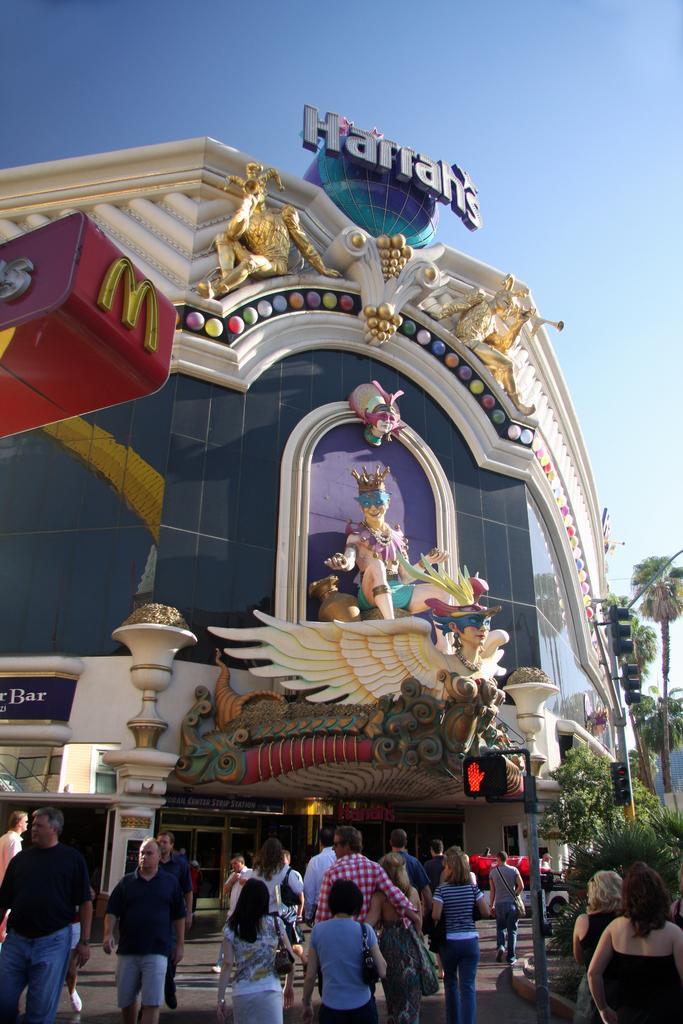How would you summarize this image in a sentence or two? In this image, I can see a building with sculptures and a name board. At the bottom of the image, there are group of people walking. On the right side of the image, I can see the trees and traffic lights to the poles. In the background, there is the sky. 